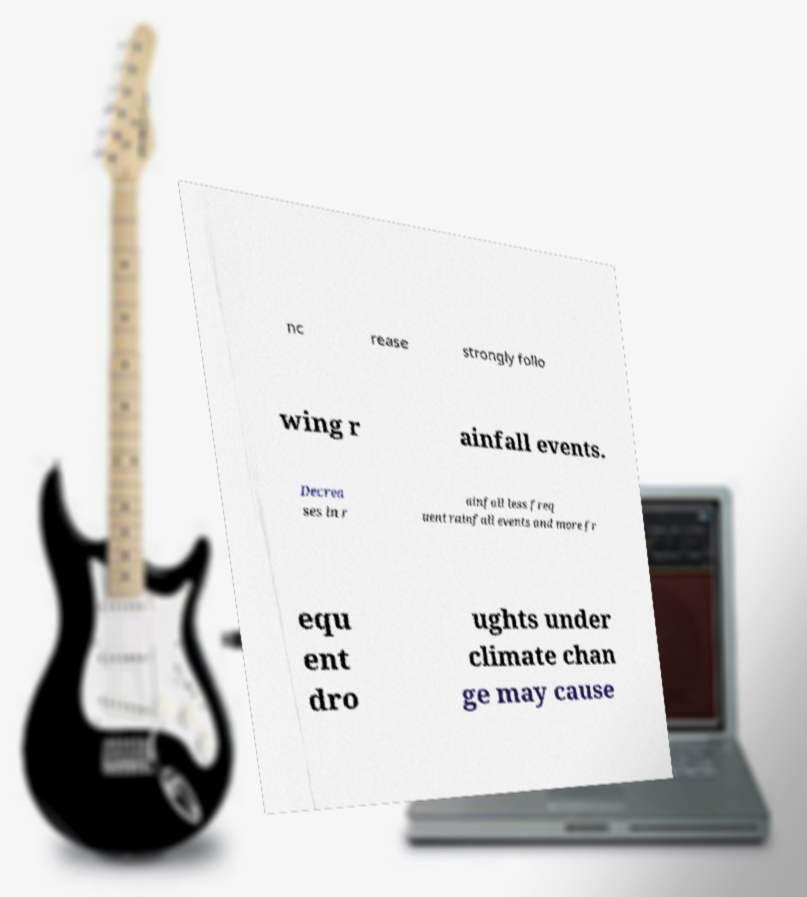For documentation purposes, I need the text within this image transcribed. Could you provide that? nc rease strongly follo wing r ainfall events. Decrea ses in r ainfall less freq uent rainfall events and more fr equ ent dro ughts under climate chan ge may cause 